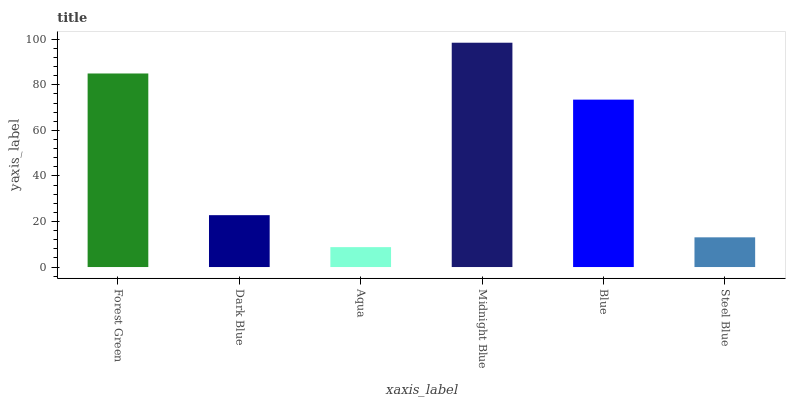Is Aqua the minimum?
Answer yes or no. Yes. Is Midnight Blue the maximum?
Answer yes or no. Yes. Is Dark Blue the minimum?
Answer yes or no. No. Is Dark Blue the maximum?
Answer yes or no. No. Is Forest Green greater than Dark Blue?
Answer yes or no. Yes. Is Dark Blue less than Forest Green?
Answer yes or no. Yes. Is Dark Blue greater than Forest Green?
Answer yes or no. No. Is Forest Green less than Dark Blue?
Answer yes or no. No. Is Blue the high median?
Answer yes or no. Yes. Is Dark Blue the low median?
Answer yes or no. Yes. Is Forest Green the high median?
Answer yes or no. No. Is Aqua the low median?
Answer yes or no. No. 